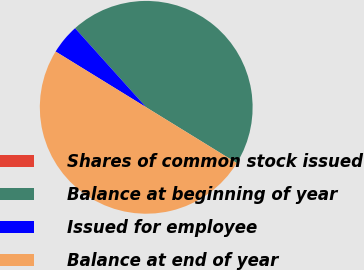<chart> <loc_0><loc_0><loc_500><loc_500><pie_chart><fcel>Shares of common stock issued<fcel>Balance at beginning of year<fcel>Issued for employee<fcel>Balance at end of year<nl><fcel>0.0%<fcel>45.44%<fcel>4.56%<fcel>50.0%<nl></chart> 